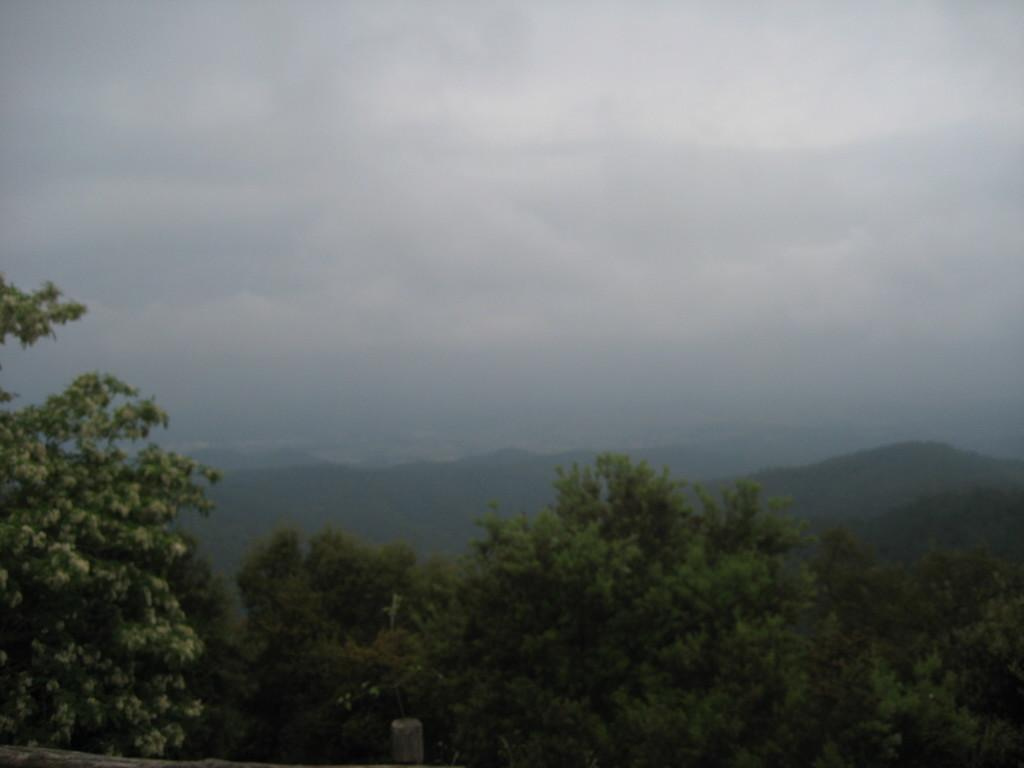What type of vegetation is at the bottom of the image? There are trees at the bottom of the image. What geographical feature is in the center of the image? There are mountains in the center of the image. What is visible at the top of the image? The sky is visible at the top of the image. Where are the houses located in the image? There are no houses present in the image. What type of engine can be seen powering the line in the image? There is no engine or line present in the image. 